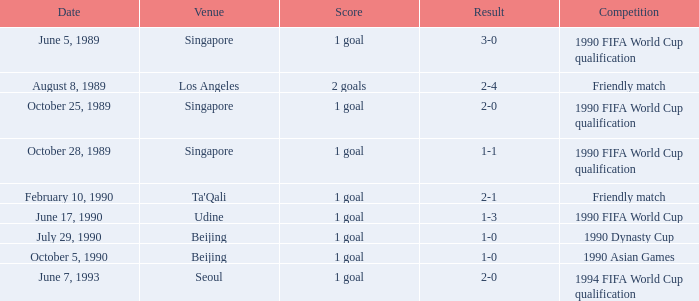What is the score of the match on October 5, 1990? 1 goal. Give me the full table as a dictionary. {'header': ['Date', 'Venue', 'Score', 'Result', 'Competition'], 'rows': [['June 5, 1989', 'Singapore', '1 goal', '3-0', '1990 FIFA World Cup qualification'], ['August 8, 1989', 'Los Angeles', '2 goals', '2-4', 'Friendly match'], ['October 25, 1989', 'Singapore', '1 goal', '2-0', '1990 FIFA World Cup qualification'], ['October 28, 1989', 'Singapore', '1 goal', '1-1', '1990 FIFA World Cup qualification'], ['February 10, 1990', "Ta'Qali", '1 goal', '2-1', 'Friendly match'], ['June 17, 1990', 'Udine', '1 goal', '1-3', '1990 FIFA World Cup'], ['July 29, 1990', 'Beijing', '1 goal', '1-0', '1990 Dynasty Cup'], ['October 5, 1990', 'Beijing', '1 goal', '1-0', '1990 Asian Games'], ['June 7, 1993', 'Seoul', '1 goal', '2-0', '1994 FIFA World Cup qualification']]} 